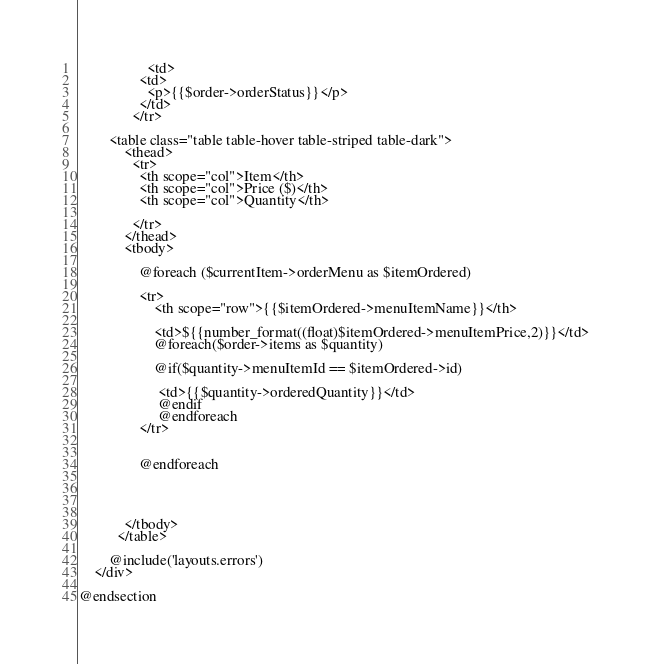<code> <loc_0><loc_0><loc_500><loc_500><_PHP_>                  <td>
                <td>     
                  <p>{{$order->orderStatus}}</p> 
                </td>
              </tr>          
           
        <table class="table table-hover table-striped table-dark">
            <thead>
              <tr>
                <th scope="col">Item</th>
                <th scope="col">Price ($)</th>
                <th scope="col">Quantity</th>
           
              </tr>
            </thead>
            <tbody>
          
                @foreach ($currentItem->orderMenu as $itemOrdered)
          
                <tr>
                    <th scope="row">{{$itemOrdered->menuItemName}}</th>
                   
                    <td>${{number_format((float)$itemOrdered->menuItemPrice,2)}}</td>
                    @foreach($order->items as $quantity)
                    
                    @if($quantity->menuItemId == $itemOrdered->id)
                     
                     <td>{{$quantity->orderedQuantity}}</td>
                     @endif
                     @endforeach 
                </tr>
             
      
                @endforeach 
                
              
             
         
            </tbody>
          </table>
       
        @include('layouts.errors')
    </div>

@endsection</code> 